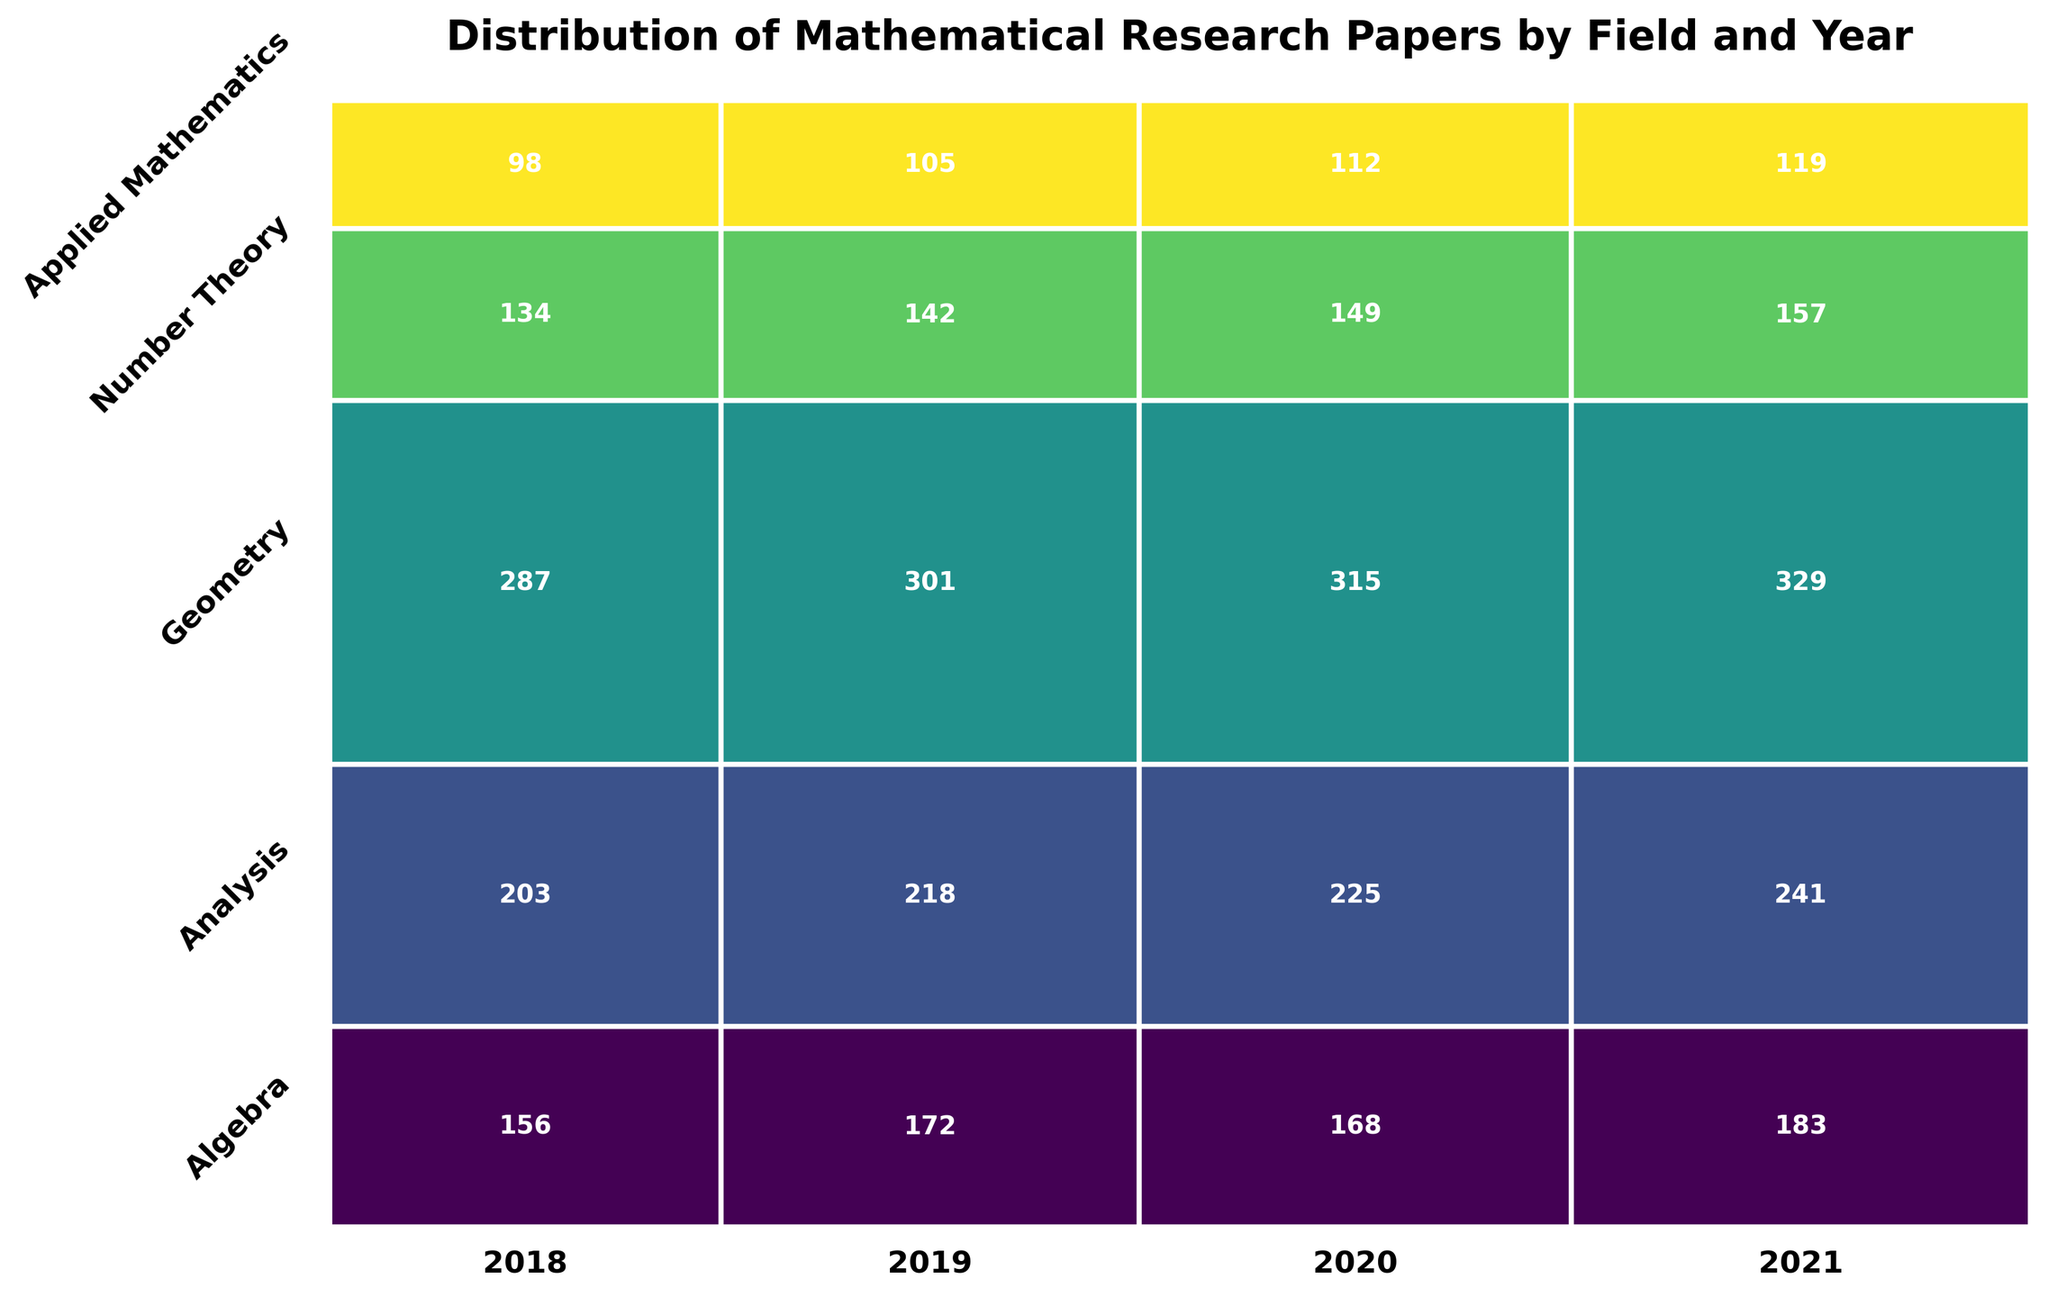What is the title of the plot? The title is typically a large and bold text that summarizes the content of the plot. In this case, it is "Distribution of Mathematical Research Papers by Field and Year"
Answer: Distribution of Mathematical Research Papers by Field and Year Which field had the highest number of publications in 2021? By looking at the width of the rectangles for 2021, we notice that the rectangle for Applied Mathematics is the widest, indicating the highest number of publications.
Answer: Applied Mathematics How many publications were there in Algebra in 2019? To find this, look for the number in the center of the rectangle corresponding to Algebra in 2019. The value is 172.
Answer: 172 What proportion of total publications in 2020 were in Analysis? First, find the width of the rectangles for 2020. Look for the Analysis rectangle and see its relative height in the 2020 band. The proportion is calculated based on the height in comparison with the entire width.
Answer: \( \frac{225}{225 + 315 + 168 + 149 + 112} \) Compare the growth in publications for Geometry between 2018 and 2021. To determine growth, subtract the number of publications in 2018 (134) from the number in 2021 (157).
Answer: \(157 - 134 = 23\) Which year had the highest total number of publications across all fields? The total number of publications is indicated by the width of the year segments. The widest segment corresponds to 2021.
Answer: 2021 What percentage of total publications in 2018 were in Number Theory? Compare the height of Number Theory’s rectangle in the 2018 segment to the total height for 2018. \( \left(\frac{98}{287 + 203 + 156 + 134 + 98}\right) \times 100 \)
Answer: About \(98 / 878 * 100\)% Is there a field that consistently increased in publication count every year from 2018 to 2021? Looking at each field across the years, count increases for Algebra, Analysis, and Applied Mathematics. Each year, the respective rectangles grow.
Answer: Yes, Algebra, Analysis, and Applied Mathematics How does the number of publications in Analysis in 2020 compare to those in Geometry in the same year? Identify the rectangles for Analysis and Geometry in 2020. Analysis has 225 publications and Geometry has 149 publications, hence Analysis has more.
Answer: Analysis > Geometry Which field had the lowest publication count in any given year? Look for the smallest rectangle in all segments. Number Theory in 2018 had the smallest count with 98 publications.
Answer: Number Theory in 2018 